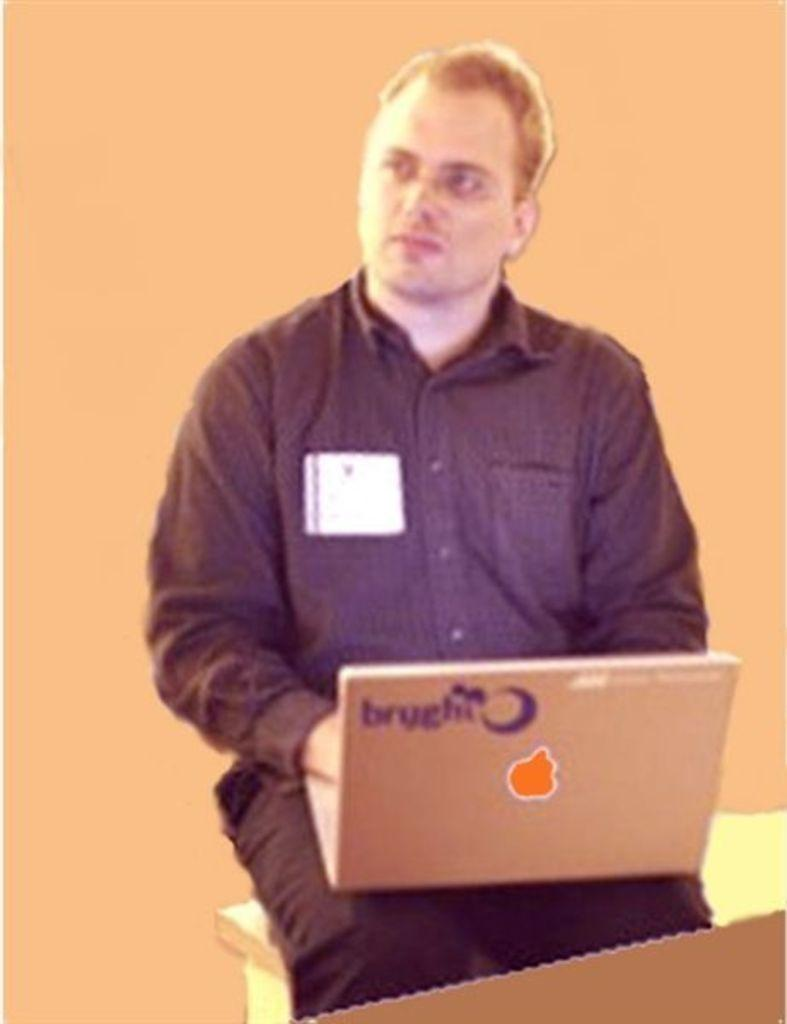What is the main subject of the image? There is a person in the image. What is the person doing in the image? The person is sitting on a stool. What object is the person holding in the image? The person is holding a laptop. What type of coal can be seen in the image? There is no coal present in the image. Is the person in the image at a shop or a hospital? The image does not provide any information about the location or context of the person, so it cannot be determined if they are at a shop or a hospital. 